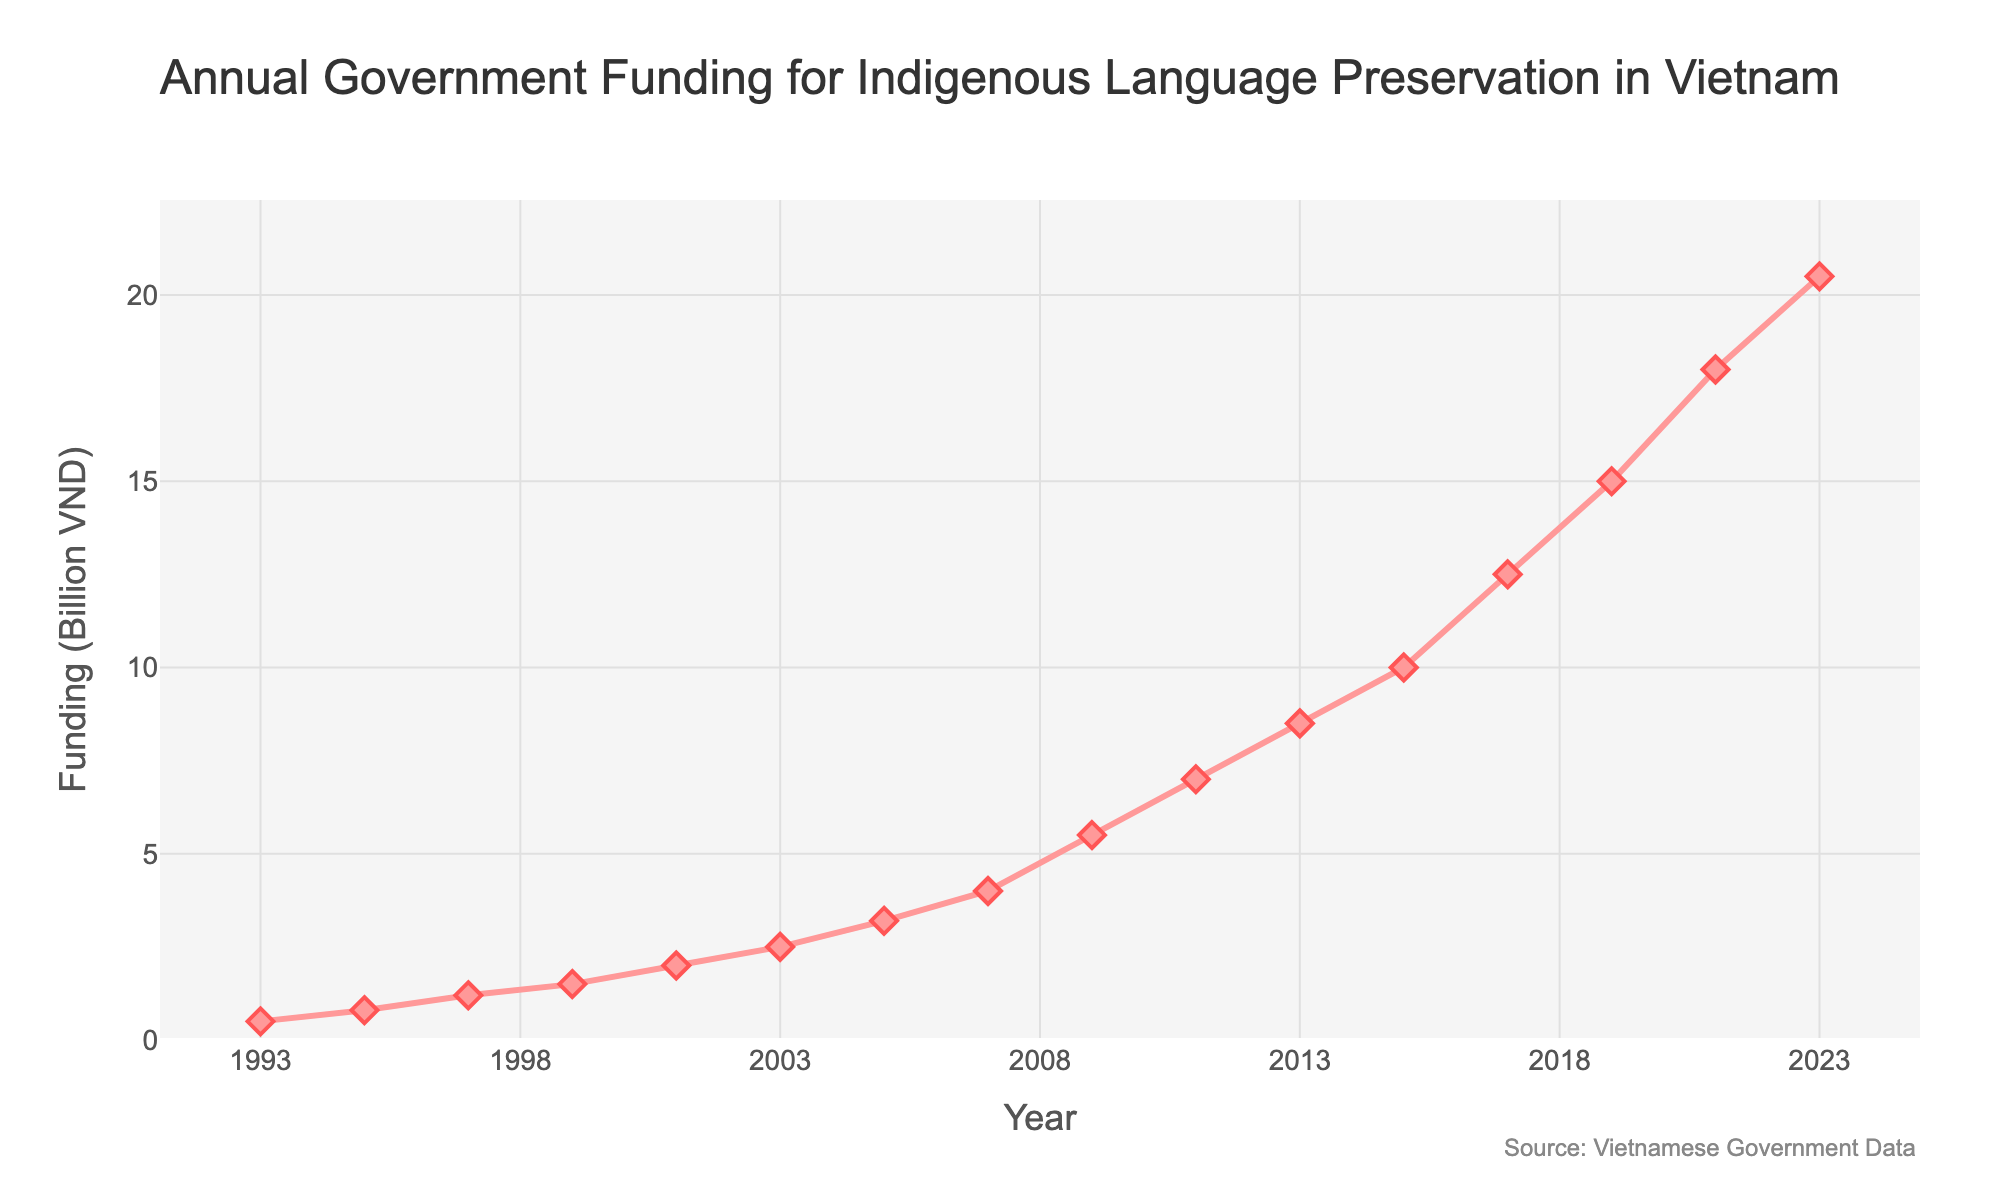What year experienced the highest increase in funding compared to the previous year? To find the year with the highest increase, we need to calculate the difference in funding between consecutive years. The largest increase is between 2021 (18.0 billion VND) and 2023 (20.5 billion VND), an increase of 2.5 billion VND.
Answer: 2023 What was the total funding allocated between 2009 and 2013? We need to add the funding amounts for the years 2009 (5.5 billion VND), 2011 (7.0 billion VND), and 2013 (8.5 billion VND). The sum is 5.5 + 7.0 + 8.5 = 21 billion VND.
Answer: 21 billion VND In which five-year period did the funding grow the most? We compare sums of funding in 5-year periods. The sums are: 1993-1997 (0.5 + 0.8 + 1.2 = 2.5), 1998-2002 (1.5 + 2.0 = 3.5), 2003-2007 (2.5 + 3.2 + 4.0 = 9.7), etc. The period from 2015 to 2019 has the largest growth, 37 billion VND.
Answer: 2015-2019 How much more funding was allocated in 2023 compared to 1993? To find the difference, subtract the funding in 1993 (0.5 billion VND) from the funding in 2023 (20.5 billion VND): 20.5 - 0.5 = 20 billion VND.
Answer: 20 billion VND What is the average annual funding from 2011 to 2023? We calculate the average of the funding values for the given years: (7.0 + 8.5 + 10.0 + 12.5 + 15.0 + 18.0 + 20.5) / 7 = 91.5 / 7 ≈ 13.07 billion VND.
Answer: 13.07 billion VND Between which two consecutive years did the funding remain the same? We examine the funding for each pair of consecutive years. There is no period where the funding remains the same between any two consecutive years in the data provided.
Answer: None How does the funding in 2009 compare to 2005? By comparing the funding amounts: in 2005 it was 3.2 billion VND and in 2009 it was 5.5 billion VND. 2009 had higher funding by 2.3 billion VND.
Answer: 2.3 billion VND more What is the color of the line representing the funding data? The line color is visually distinguishable in the generated figure. The line representing the data is a shade of red.
Answer: Red 